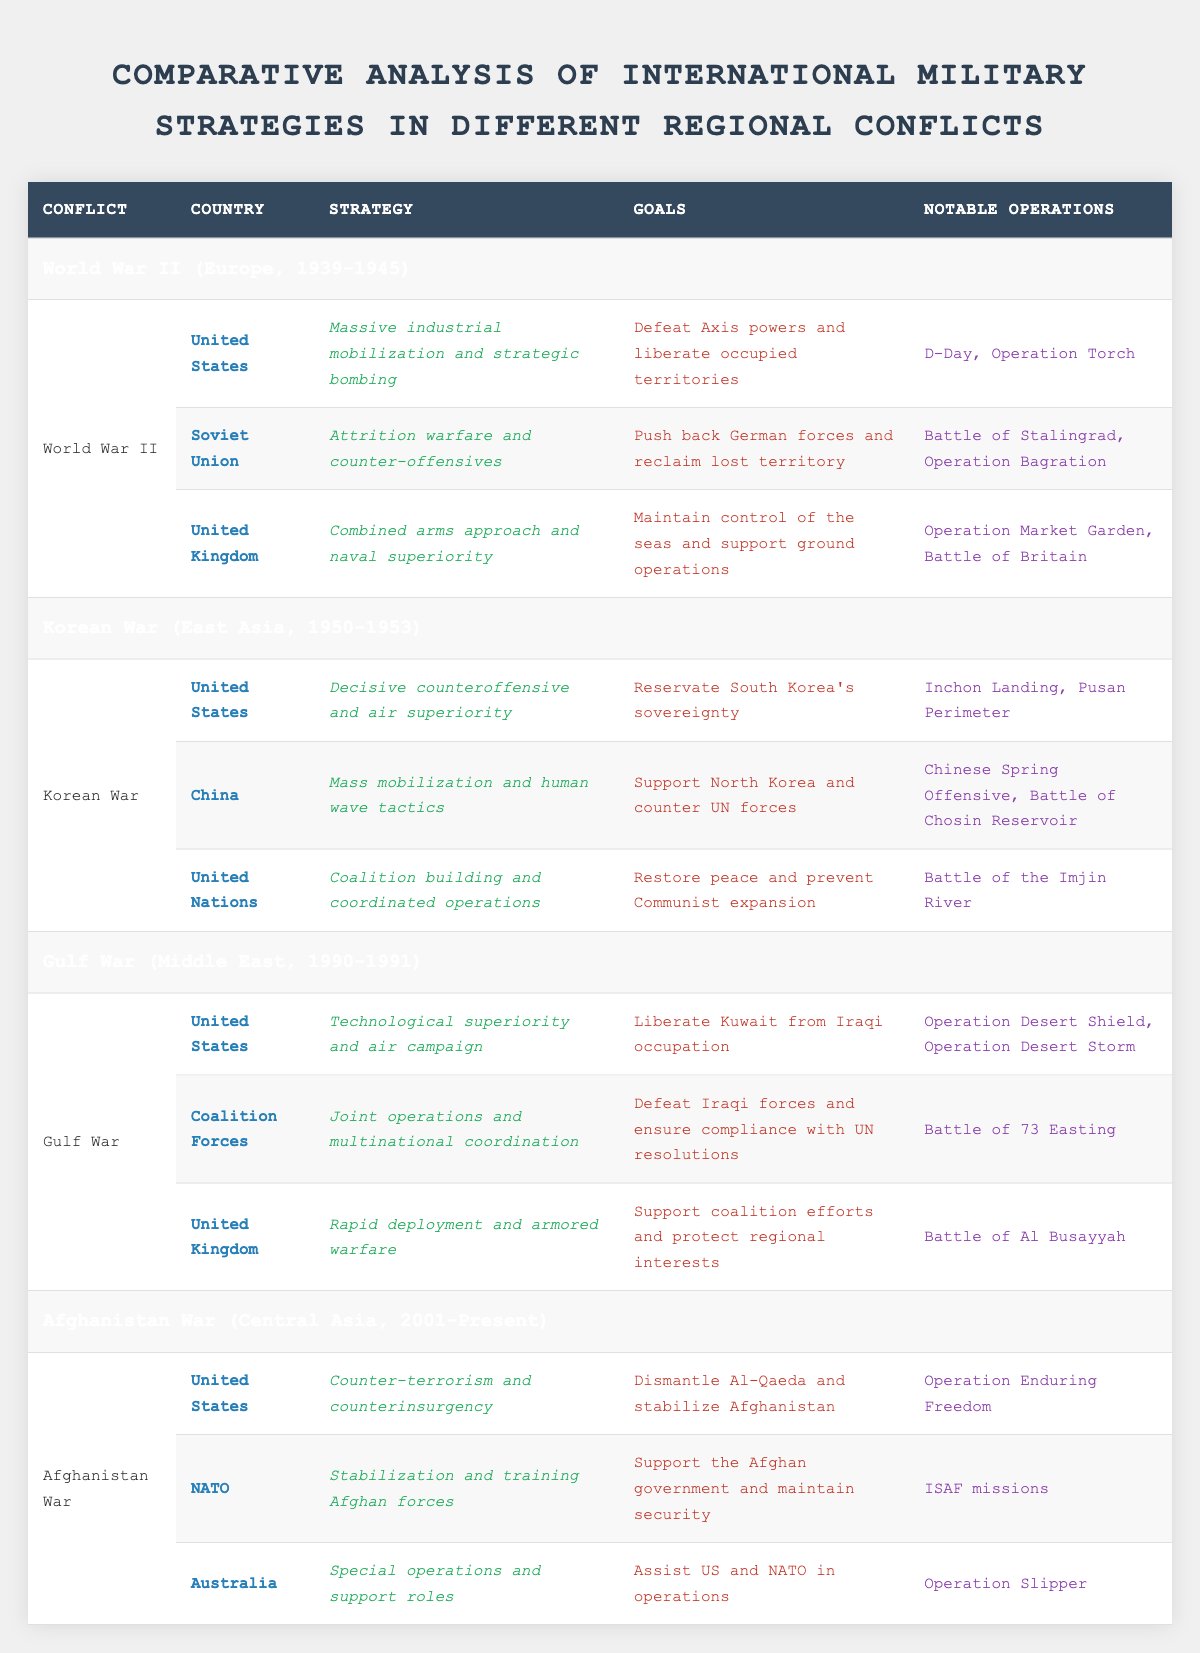What were the notable operations of the United States during World War II? The notable operations of the United States during World War II, as listed in the table, include D-Day and Operation Torch. These operations were significant efforts in the context of the larger conflict against the Axis powers.
Answer: D-Day, Operation Torch Which country had a strategy based on attrition warfare during World War II? According to the table, the Soviet Union had a strategy based on attrition warfare and counter-offensives during World War II. This strategy was aimed at pushing back German forces and reclaiming lost territory.
Answer: Soviet Union Did the United Nations participate in the Gulf War? The table indicates that the United Nations did not participate in the Gulf War; therefore, the answer is no. The international forces listed include the United States, Coalition Forces, and the United Kingdom, but not the United Nations.
Answer: No What were the strategies of the United States in both the Korean War and the Gulf War? For the Korean War, the United States employed a strategy of decisive counteroffensive and air superiority. In the Gulf War, the strategy was technological superiority and air campaign. This means the U.S. focused on different strategic approaches for each conflict, adjusting to the specific circumstances.
Answer: Different strategies How many notable operations did the UK conduct in the Gulf War? The United Kingdom conducted one notable operation in the Gulf War, which is the Battle of Al Busayyah, as indicated in the table. This means the UK was involved in a supportive role during the coalition efforts with this single noted action.
Answer: One notable operation Which country's strategy involved mass mobilization in the Korean War? The table shows that China’s strategy in the Korean War involved mass mobilization and human wave tactics. This indicates a focus on utilizing large numbers of troops effectively in their military operations.
Answer: China What is the primary goal of NATO's involvement in the Afghanistan War? The table states that NATO's primary goal in the Afghanistan War was to support the Afghan government and maintain security. This indicates their role was centered around stabilization efforts rather than direct aggression.
Answer: Support Afghan government and maintain security Compare the strategies of the United States in World War II and the Afghanistan War. In World War II, the United States utilized massive industrial mobilization and strategic bombing, aiming to defeat Axis powers. In contrast, their strategy in the Afghanistan War centered on counter-terrorism and counterinsurgency, with the goal of dismantling Al-Qaeda and stabilizing Afghanistan. This comparison shows a shift from large-scale military operations to a targeted approach against terrorism.
Answer: Shift in strategy from massive mobilization to counter-terrorism 